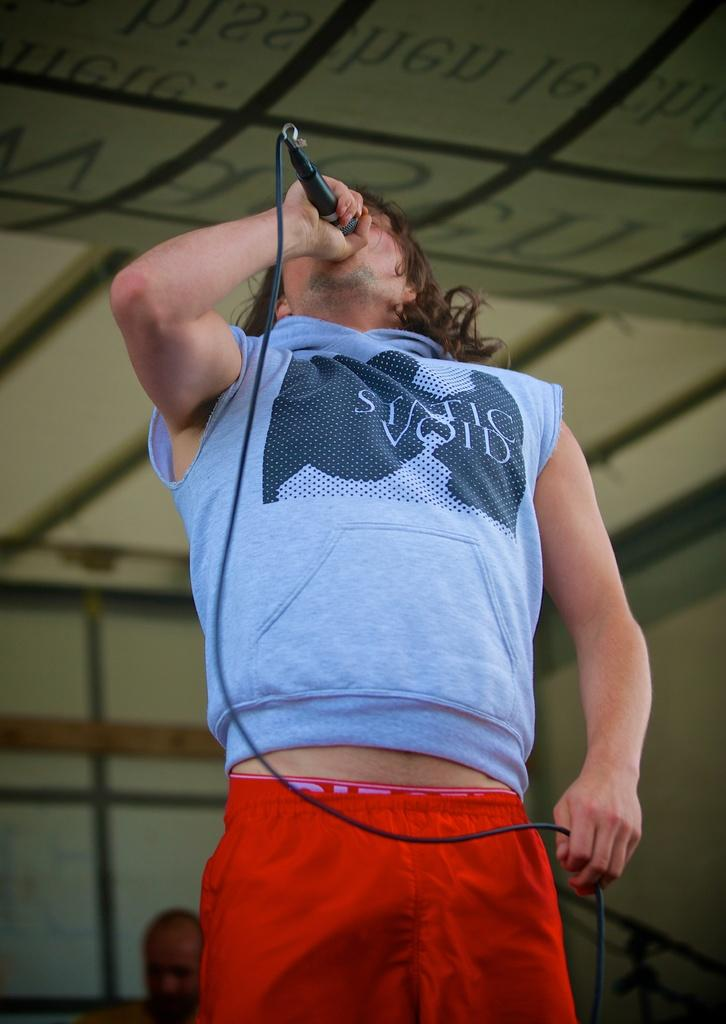<image>
Create a compact narrative representing the image presented. A man signing on stage with the phrase STATIC VOID written on his shirt. 